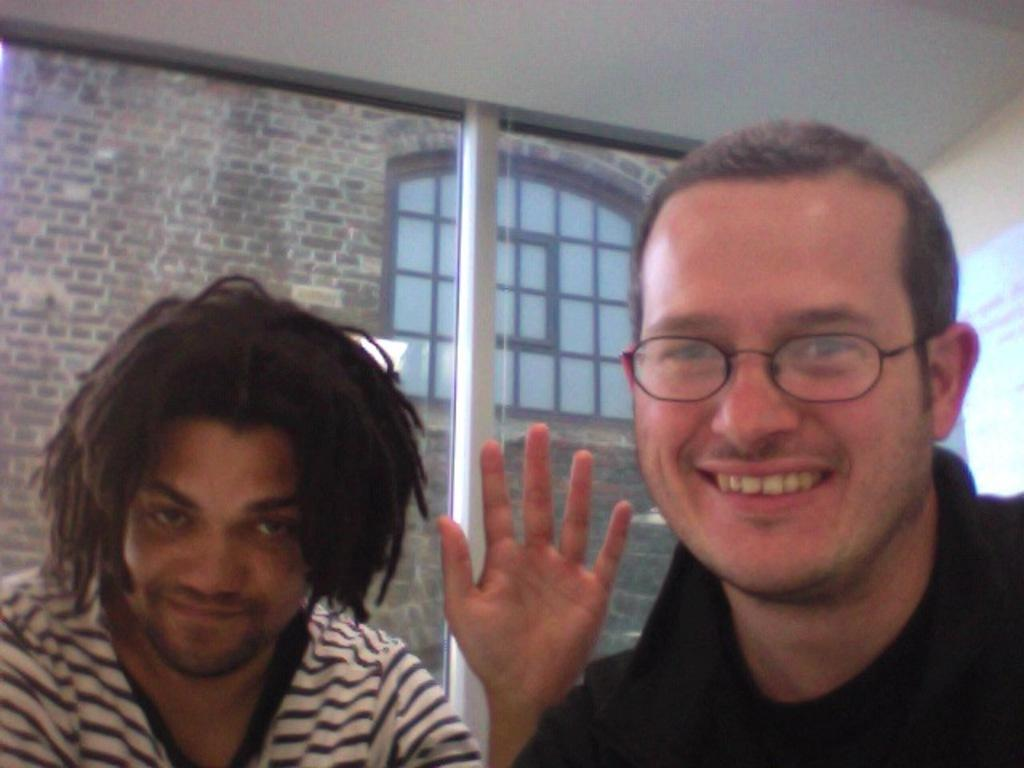How many people are in the image? There are two persons in the image. Can you describe any distinguishing features of one of the persons? One of the persons is wearing spectacles. What type of string is being used by the secretary in the image? There is no secretary or string present in the image. 